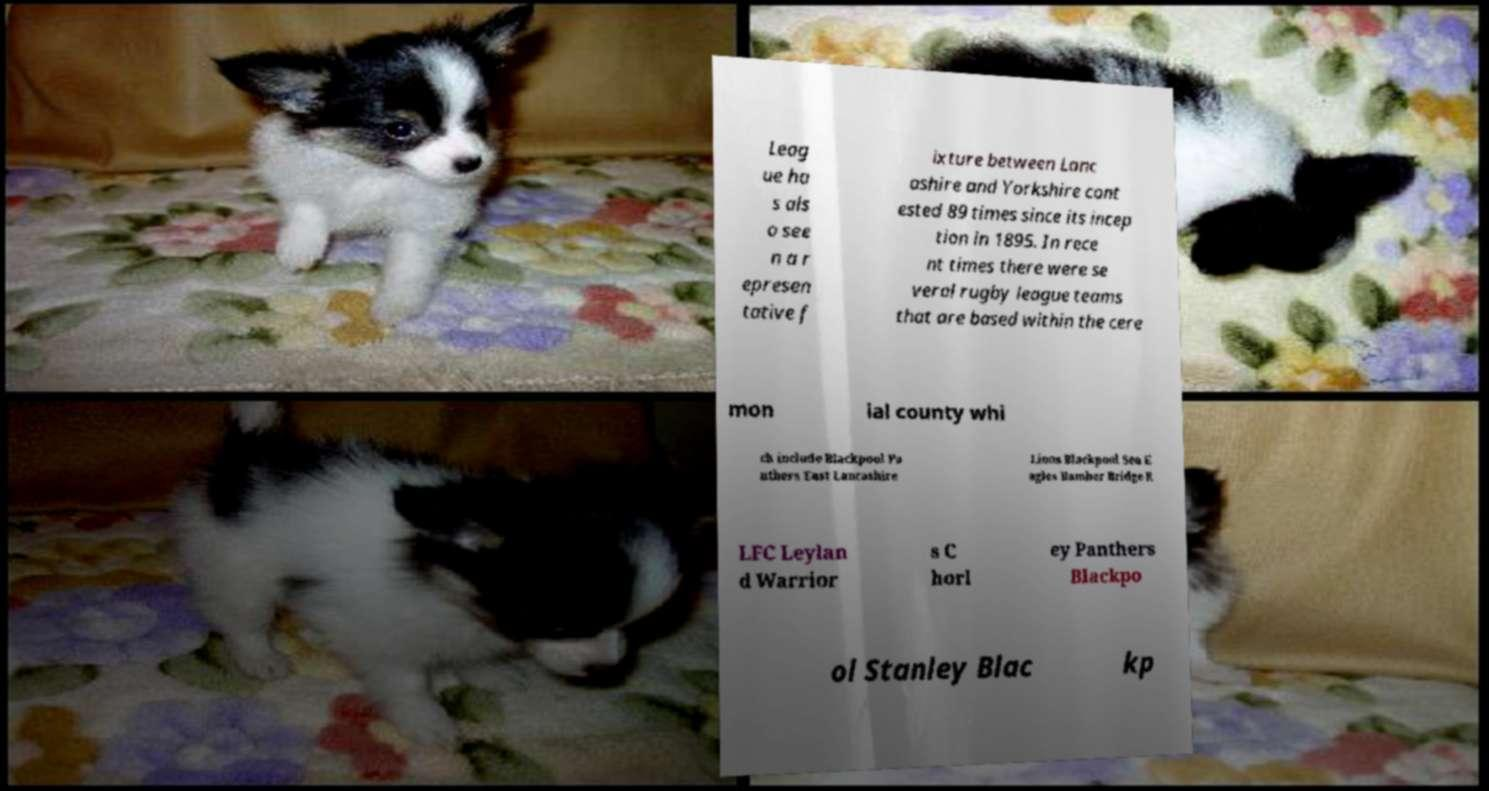Could you assist in decoding the text presented in this image and type it out clearly? Leag ue ha s als o see n a r epresen tative f ixture between Lanc ashire and Yorkshire cont ested 89 times since its incep tion in 1895. In rece nt times there were se veral rugby league teams that are based within the cere mon ial county whi ch include Blackpool Pa nthers East Lancashire Lions Blackpool Sea E agles Bamber Bridge R LFC Leylan d Warrior s C horl ey Panthers Blackpo ol Stanley Blac kp 